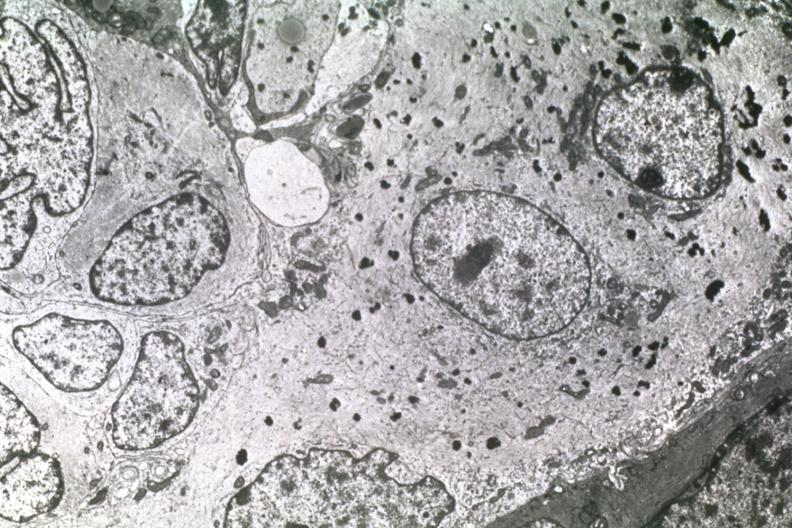does metastatic carcinoma prostate show dr garcia tumors 25?
Answer the question using a single word or phrase. No 